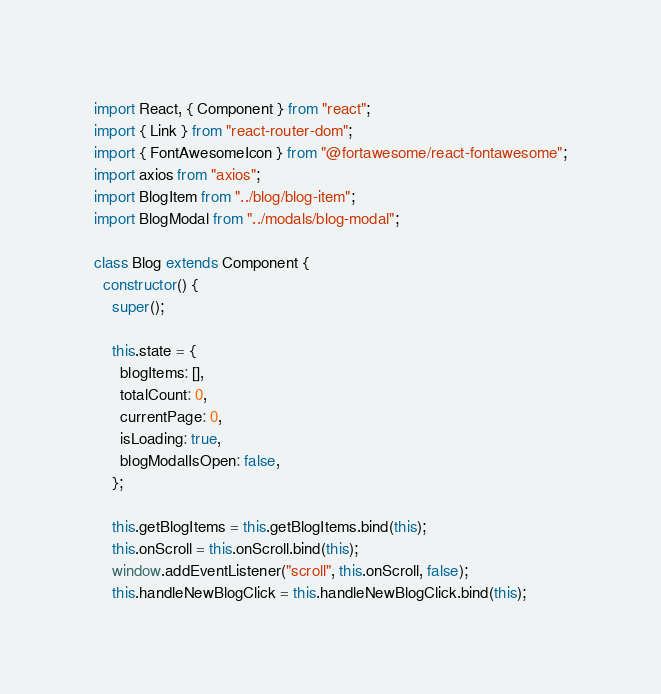<code> <loc_0><loc_0><loc_500><loc_500><_JavaScript_>import React, { Component } from "react";
import { Link } from "react-router-dom";
import { FontAwesomeIcon } from "@fortawesome/react-fontawesome";
import axios from "axios";
import BlogItem from "../blog/blog-item";
import BlogModal from "../modals/blog-modal";

class Blog extends Component {
  constructor() {
    super();

    this.state = {
      blogItems: [],
      totalCount: 0,
      currentPage: 0,
      isLoading: true,
      blogModalIsOpen: false,
    };

    this.getBlogItems = this.getBlogItems.bind(this);
    this.onScroll = this.onScroll.bind(this);
    window.addEventListener("scroll", this.onScroll, false);
    this.handleNewBlogClick = this.handleNewBlogClick.bind(this);</code> 